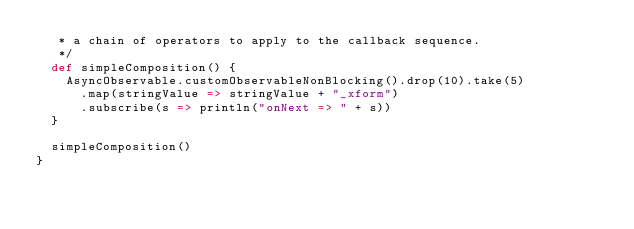<code> <loc_0><loc_0><loc_500><loc_500><_Scala_>   * a chain of operators to apply to the callback sequence.
   */
  def simpleComposition() {
    AsyncObservable.customObservableNonBlocking().drop(10).take(5)
      .map(stringValue => stringValue + "_xform")
      .subscribe(s => println("onNext => " + s))
  }

  simpleComposition()
}
</code> 